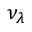Convert formula to latex. <formula><loc_0><loc_0><loc_500><loc_500>\nu _ { \lambda }</formula> 